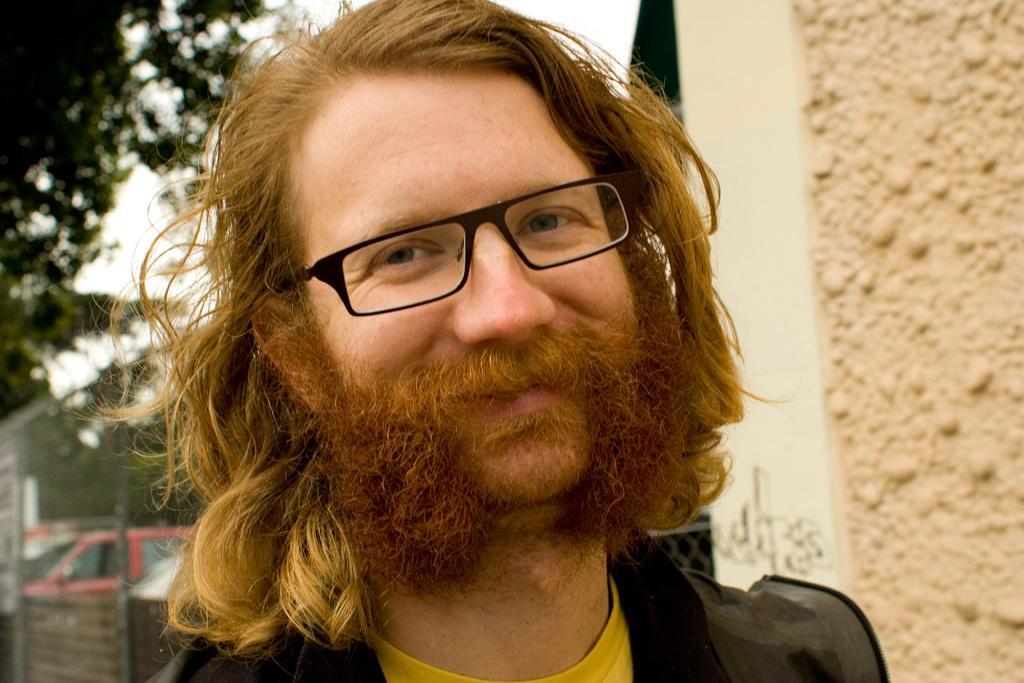How would you summarize this image in a sentence or two? In this image we can see a person wearing specs. On the right side there is a wall. In the background it is looking blur. 